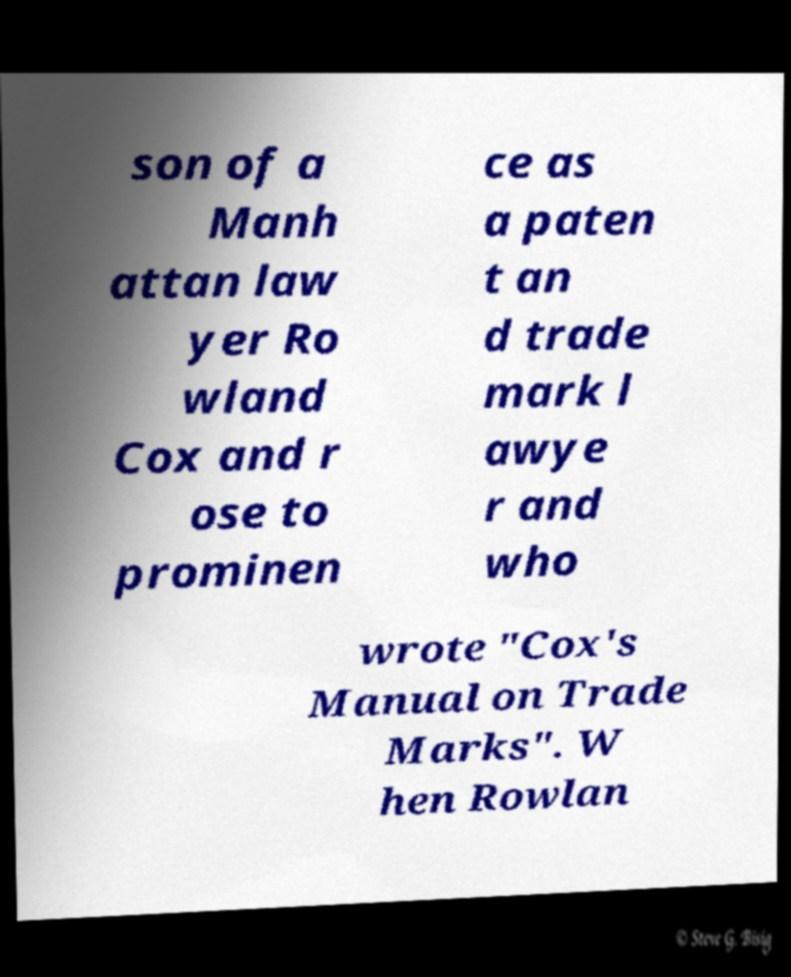Can you accurately transcribe the text from the provided image for me? son of a Manh attan law yer Ro wland Cox and r ose to prominen ce as a paten t an d trade mark l awye r and who wrote "Cox's Manual on Trade Marks". W hen Rowlan 